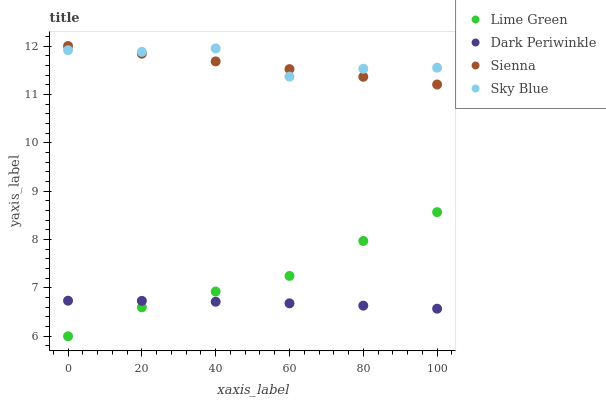Does Dark Periwinkle have the minimum area under the curve?
Answer yes or no. Yes. Does Sky Blue have the maximum area under the curve?
Answer yes or no. Yes. Does Lime Green have the minimum area under the curve?
Answer yes or no. No. Does Lime Green have the maximum area under the curve?
Answer yes or no. No. Is Sienna the smoothest?
Answer yes or no. Yes. Is Sky Blue the roughest?
Answer yes or no. Yes. Is Lime Green the smoothest?
Answer yes or no. No. Is Lime Green the roughest?
Answer yes or no. No. Does Lime Green have the lowest value?
Answer yes or no. Yes. Does Sky Blue have the lowest value?
Answer yes or no. No. Does Sienna have the highest value?
Answer yes or no. Yes. Does Sky Blue have the highest value?
Answer yes or no. No. Is Lime Green less than Sky Blue?
Answer yes or no. Yes. Is Sky Blue greater than Lime Green?
Answer yes or no. Yes. Does Dark Periwinkle intersect Lime Green?
Answer yes or no. Yes. Is Dark Periwinkle less than Lime Green?
Answer yes or no. No. Is Dark Periwinkle greater than Lime Green?
Answer yes or no. No. Does Lime Green intersect Sky Blue?
Answer yes or no. No. 